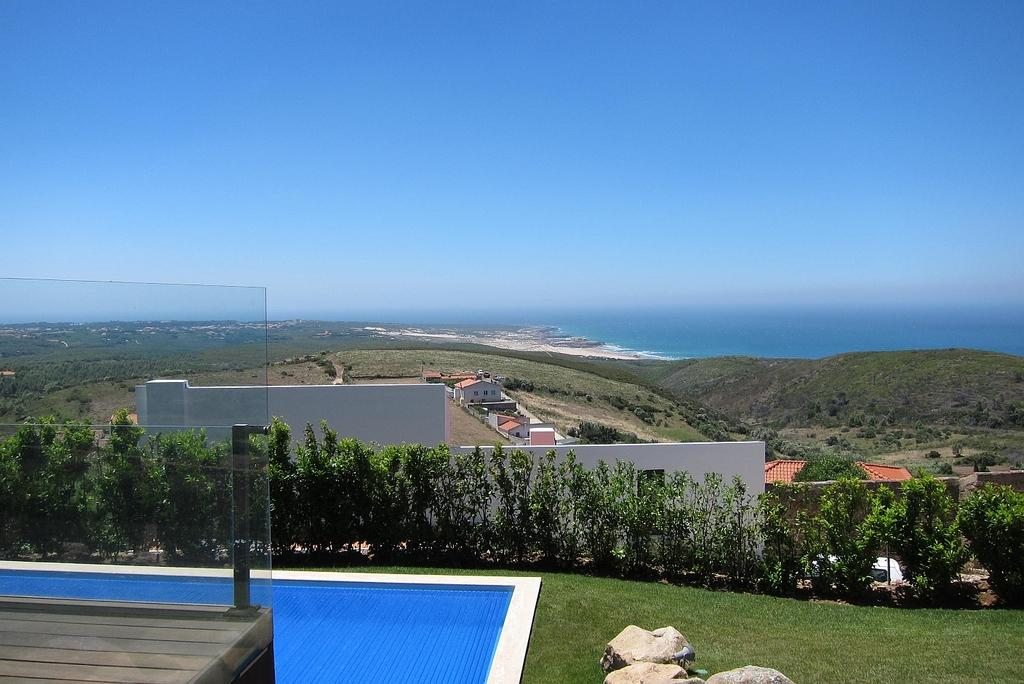What type of natural elements can be seen in the image? There are rocks and grass visible in the image. What man-made structure is present in the image? There is a swimming pool in the image. What type of vegetation can be seen in the image? There are plants in the image. What type of buildings are visible in the image? There are houses in the image. What material is present in the image? There is glass in the image. What can be seen in the background of the image? Water and the sky are visible in the background of the image. Can you tell me how many snails are crawling on the glass in the image? There are no snails present in the image. What type of shop can be seen in the background of the image? There is no shop visible in the image. 